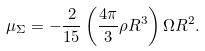<formula> <loc_0><loc_0><loc_500><loc_500>\mu _ { \Sigma } = - \frac { 2 } { 1 5 } \left ( { \frac { 4 \pi } { 3 } \rho { R ^ { 3 } } } \right ) \Omega { R ^ { 2 } } .</formula> 